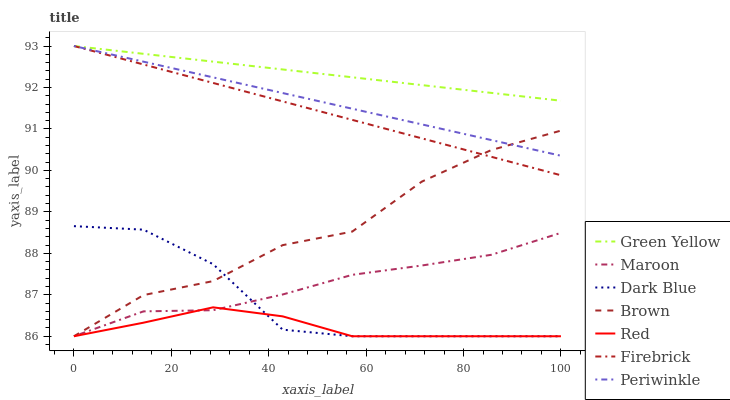Does Red have the minimum area under the curve?
Answer yes or no. Yes. Does Green Yellow have the maximum area under the curve?
Answer yes or no. Yes. Does Firebrick have the minimum area under the curve?
Answer yes or no. No. Does Firebrick have the maximum area under the curve?
Answer yes or no. No. Is Periwinkle the smoothest?
Answer yes or no. Yes. Is Brown the roughest?
Answer yes or no. Yes. Is Firebrick the smoothest?
Answer yes or no. No. Is Firebrick the roughest?
Answer yes or no. No. Does Brown have the lowest value?
Answer yes or no. Yes. Does Firebrick have the lowest value?
Answer yes or no. No. Does Green Yellow have the highest value?
Answer yes or no. Yes. Does Maroon have the highest value?
Answer yes or no. No. Is Maroon less than Periwinkle?
Answer yes or no. Yes. Is Periwinkle greater than Red?
Answer yes or no. Yes. Does Brown intersect Periwinkle?
Answer yes or no. Yes. Is Brown less than Periwinkle?
Answer yes or no. No. Is Brown greater than Periwinkle?
Answer yes or no. No. Does Maroon intersect Periwinkle?
Answer yes or no. No. 